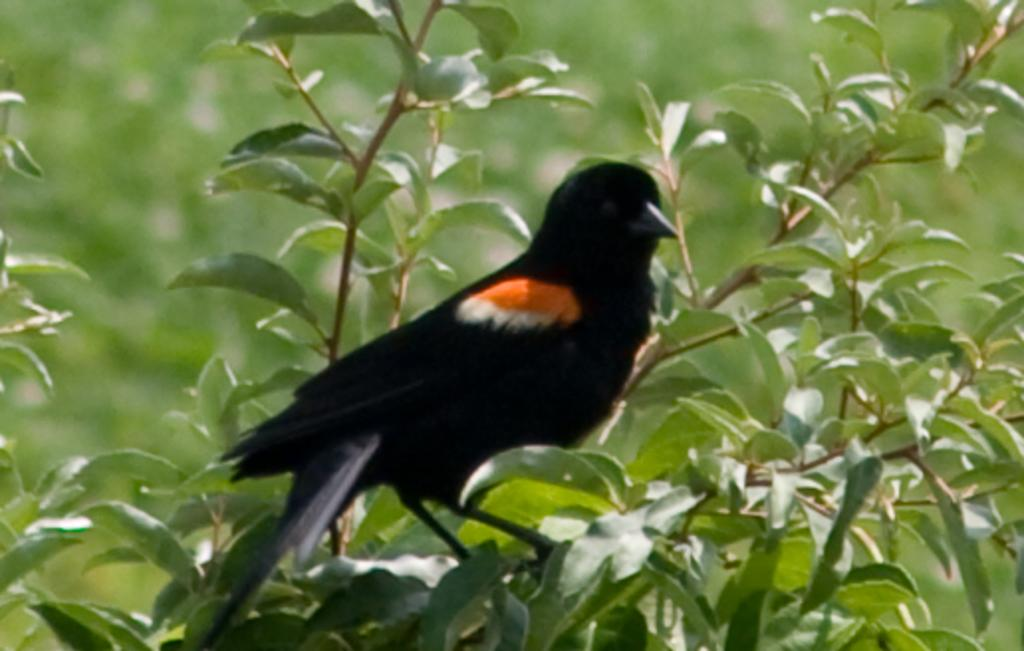What is the main subject of the image? The main subject of the image is a tree with its trunk cut off. Is there any wildlife present in the image? Yes, there is a bird on the tree. Can you describe the background of the image? The background of the image is blurred. How many kittens are sleeping on the quilt in the image? There is no quilt or kittens present in the image. What is the income of the person who took the photo? The income of the person who took the photo is not mentioned or visible in the image. 